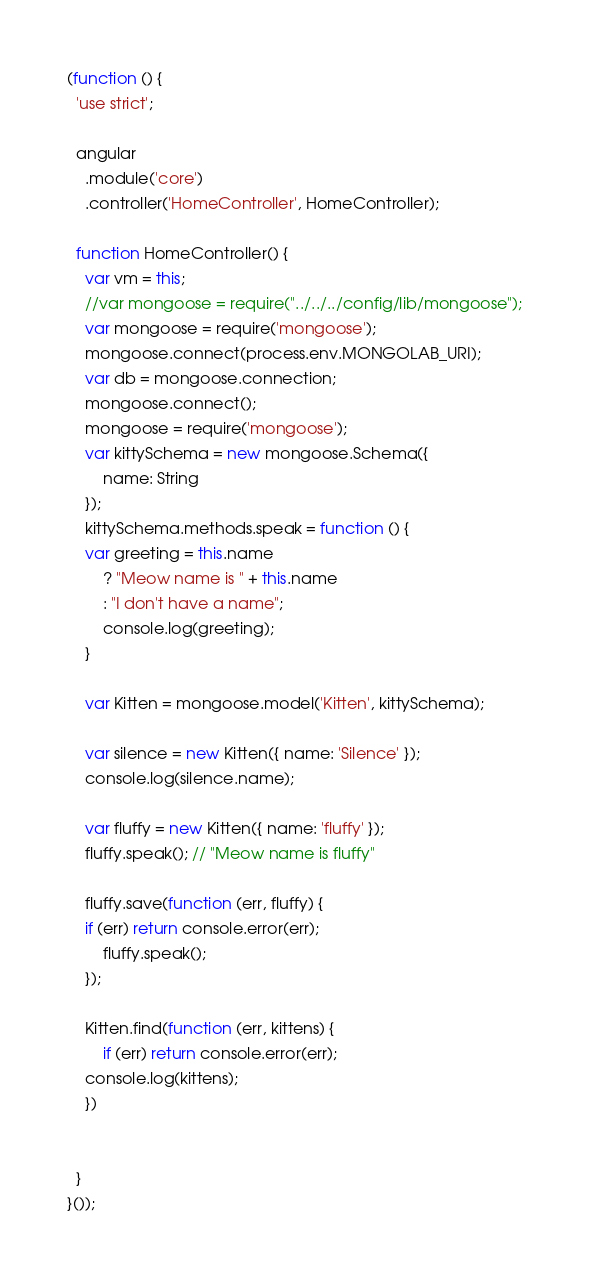Convert code to text. <code><loc_0><loc_0><loc_500><loc_500><_JavaScript_>(function () {
  'use strict';

  angular
    .module('core')
    .controller('HomeController', HomeController);

  function HomeController() {
    var vm = this;
    //var mongoose = require("../../../config/lib/mongoose");
    var mongoose = require('mongoose');
    mongoose.connect(process.env.MONGOLAB_URI);
    var db = mongoose.connection;
    mongoose.connect();
    mongoose = require('mongoose');
    var kittySchema = new mongoose.Schema({
  		name: String
	});
	kittySchema.methods.speak = function () {
  	var greeting = this.name
    	? "Meow name is " + this.name
    	: "I don't have a name";
  		console.log(greeting);
	}

	var Kitten = mongoose.model('Kitten', kittySchema);

	var silence = new Kitten({ name: 'Silence' });
	console.log(silence.name);

	var fluffy = new Kitten({ name: 'fluffy' });
	fluffy.speak(); // "Meow name is fluffy"

	fluffy.save(function (err, fluffy) {
    if (err) return console.error(err);
    	fluffy.speak();
  	});

  	Kitten.find(function (err, kittens) {
  		if (err) return console.error(err);
  	console.log(kittens);
	})


  }
}());
</code> 